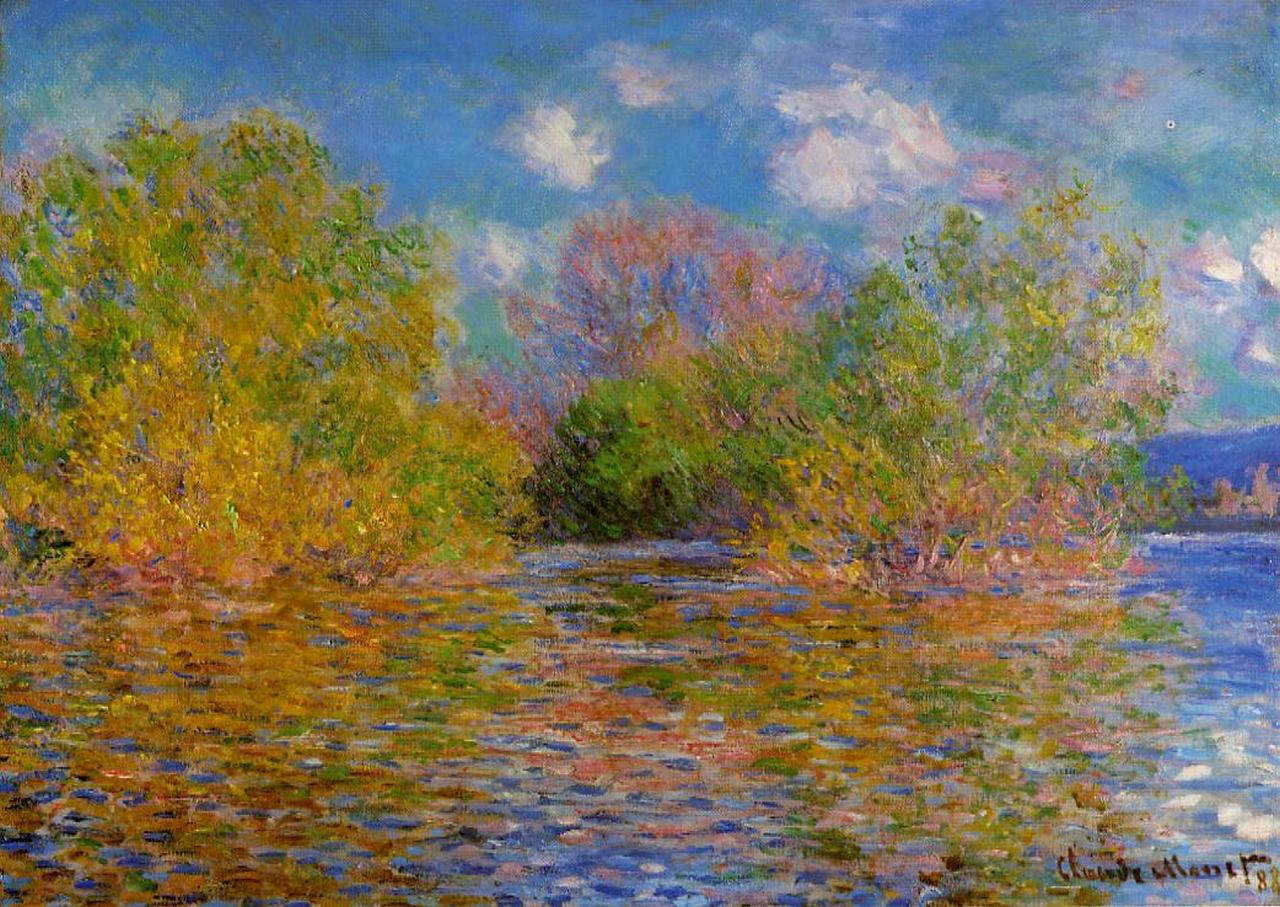What do you find most striking about this painting? What strikes me most about this painting is the interplay of colors and the ethereal quality of the light. Monet's ability to capture the essence of the soft sunlight glinting off the water, combined with the vibrant and yet subtly blended colors of the foliage, creates a scene that feels both intensely real and dreamlike. His brushwork conveys motion and atmosphere, making the scene come alive in a way that is both serene and dynamic. If this painting could tell a story from its own perspective, what would it say? I am a moment frozen in time, a serene afternoon by the river where the air is warm, the water is calm, and nature is at peace. I capture the delicate dance of light upon the leaves and water, the whispers of the breeze, and the silent reflections of the sky. I am a testament to the beauty that exists just beyond the bustle of daily life, a reminder of the quiet, enduring elegance of the natural world. My colors may fade over time, but the tranquility and the fleeting joy I represent will linger in the hearts of those who gaze upon me. Create a haiku inspired by the painting. Golden leaves whisper,
Sunlit ripples gently play,
Nature’s quiet voice. 